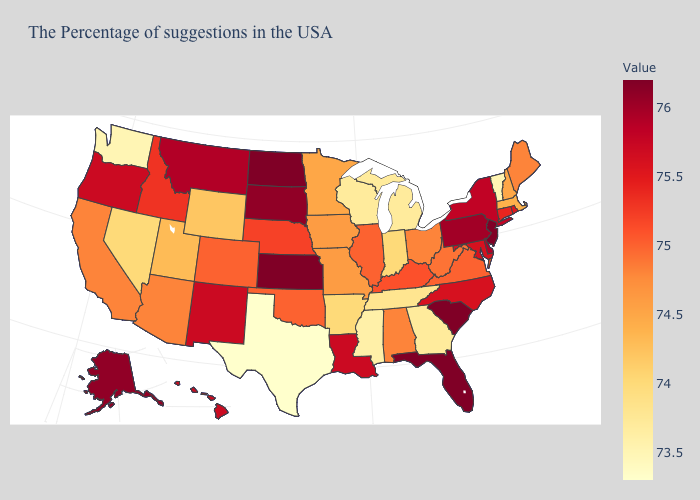Which states have the lowest value in the West?
Answer briefly. Washington. Among the states that border Maryland , does West Virginia have the lowest value?
Keep it brief. Yes. Which states have the lowest value in the USA?
Write a very short answer. Texas. Which states have the highest value in the USA?
Short answer required. New Jersey, South Carolina, Florida, Kansas, North Dakota. 